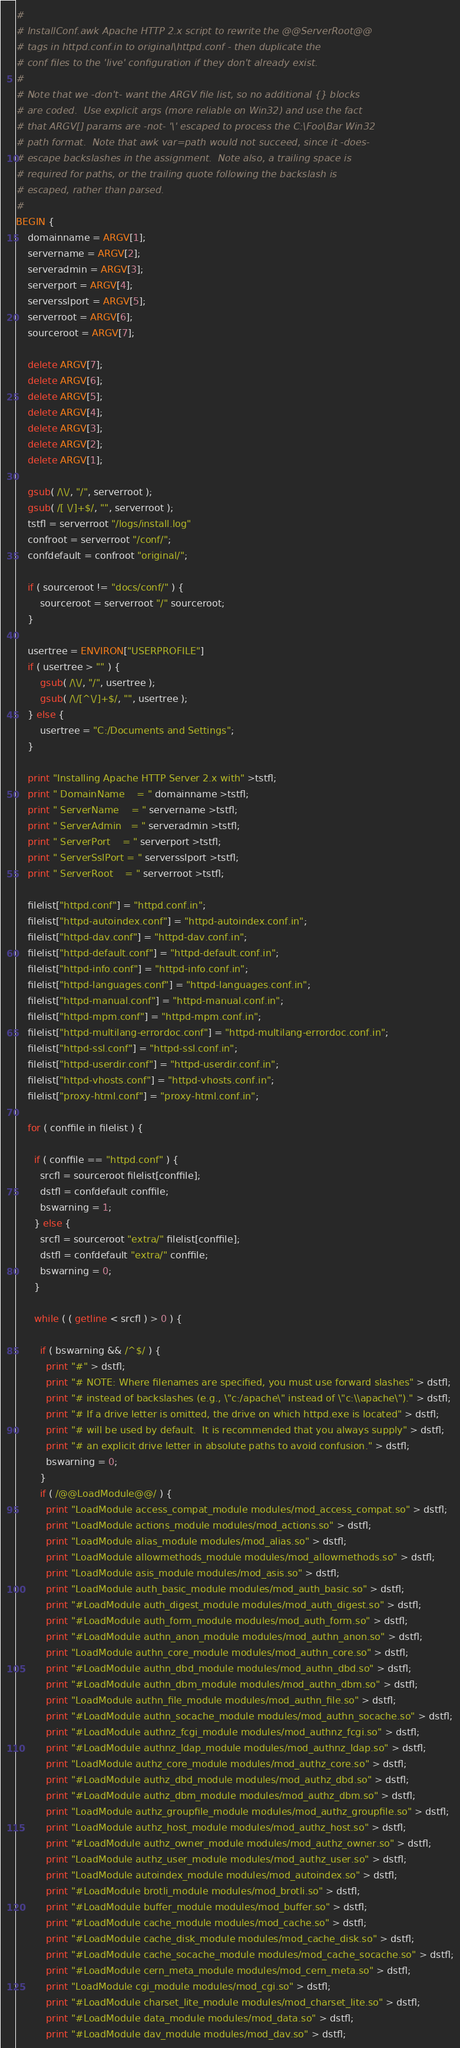<code> <loc_0><loc_0><loc_500><loc_500><_Awk_>#
# InstallConf.awk Apache HTTP 2.x script to rewrite the @@ServerRoot@@
# tags in httpd.conf.in to original\httpd.conf - then duplicate the
# conf files to the 'live' configuration if they don't already exist.
#
# Note that we -don't- want the ARGV file list, so no additional {} blocks
# are coded.  Use explicit args (more reliable on Win32) and use the fact
# that ARGV[] params are -not- '\' escaped to process the C:\Foo\Bar Win32
# path format.  Note that awk var=path would not succeed, since it -does-
# escape backslashes in the assignment.  Note also, a trailing space is
# required for paths, or the trailing quote following the backslash is
# escaped, rather than parsed.
#
BEGIN {
    domainname = ARGV[1];
    servername = ARGV[2];
    serveradmin = ARGV[3];
    serverport = ARGV[4];
    serversslport = ARGV[5];
    serverroot = ARGV[6];
    sourceroot = ARGV[7];

    delete ARGV[7];
    delete ARGV[6];
    delete ARGV[5];
    delete ARGV[4];
    delete ARGV[3];
    delete ARGV[2];
    delete ARGV[1];

    gsub( /\\/, "/", serverroot );
    gsub( /[ \/]+$/, "", serverroot );
    tstfl = serverroot "/logs/install.log"
    confroot = serverroot "/conf/";
    confdefault = confroot "original/";

    if ( sourceroot != "docs/conf/" ) {
        sourceroot = serverroot "/" sourceroot;
    }

    usertree = ENVIRON["USERPROFILE"]
    if ( usertree > "" ) {
        gsub( /\\/, "/", usertree );
        gsub( /\/[^\/]+$/, "", usertree );
    } else {
        usertree = "C:/Documents and Settings";
    }

    print "Installing Apache HTTP Server 2.x with" >tstfl;
    print " DomainName    = " domainname >tstfl;
    print " ServerName    = " servername >tstfl;
    print " ServerAdmin   = " serveradmin >tstfl;
    print " ServerPort    = " serverport >tstfl;
    print " ServerSslPort = " serversslport >tstfl;
    print " ServerRoot    = " serverroot >tstfl;

    filelist["httpd.conf"] = "httpd.conf.in";
    filelist["httpd-autoindex.conf"] = "httpd-autoindex.conf.in";
    filelist["httpd-dav.conf"] = "httpd-dav.conf.in";
    filelist["httpd-default.conf"] = "httpd-default.conf.in";
    filelist["httpd-info.conf"] = "httpd-info.conf.in";
    filelist["httpd-languages.conf"] = "httpd-languages.conf.in";
    filelist["httpd-manual.conf"] = "httpd-manual.conf.in";
    filelist["httpd-mpm.conf"] = "httpd-mpm.conf.in";
    filelist["httpd-multilang-errordoc.conf"] = "httpd-multilang-errordoc.conf.in";
    filelist["httpd-ssl.conf"] = "httpd-ssl.conf.in";
    filelist["httpd-userdir.conf"] = "httpd-userdir.conf.in";
    filelist["httpd-vhosts.conf"] = "httpd-vhosts.conf.in";
    filelist["proxy-html.conf"] = "proxy-html.conf.in";

    for ( conffile in filelist ) {

      if ( conffile == "httpd.conf" ) {
        srcfl = sourceroot filelist[conffile];
        dstfl = confdefault conffile;
        bswarning = 1;
      } else {
        srcfl = sourceroot "extra/" filelist[conffile];
        dstfl = confdefault "extra/" conffile;
        bswarning = 0;
      }

      while ( ( getline < srcfl ) > 0 ) {

        if ( bswarning && /^$/ ) {
          print "#" > dstfl;
          print "# NOTE: Where filenames are specified, you must use forward slashes" > dstfl;
          print "# instead of backslashes (e.g., \"c:/apache\" instead of \"c:\\apache\")." > dstfl;
          print "# If a drive letter is omitted, the drive on which httpd.exe is located" > dstfl;
          print "# will be used by default.  It is recommended that you always supply" > dstfl;
          print "# an explicit drive letter in absolute paths to avoid confusion." > dstfl;
          bswarning = 0;
        }
        if ( /@@LoadModule@@/ ) {
          print "LoadModule access_compat_module modules/mod_access_compat.so" > dstfl;
          print "LoadModule actions_module modules/mod_actions.so" > dstfl;
          print "LoadModule alias_module modules/mod_alias.so" > dstfl;
          print "LoadModule allowmethods_module modules/mod_allowmethods.so" > dstfl;
          print "LoadModule asis_module modules/mod_asis.so" > dstfl;
          print "LoadModule auth_basic_module modules/mod_auth_basic.so" > dstfl;
          print "#LoadModule auth_digest_module modules/mod_auth_digest.so" > dstfl;
          print "#LoadModule auth_form_module modules/mod_auth_form.so" > dstfl;
          print "#LoadModule authn_anon_module modules/mod_authn_anon.so" > dstfl;
          print "LoadModule authn_core_module modules/mod_authn_core.so" > dstfl;
          print "#LoadModule authn_dbd_module modules/mod_authn_dbd.so" > dstfl;
          print "#LoadModule authn_dbm_module modules/mod_authn_dbm.so" > dstfl;
          print "LoadModule authn_file_module modules/mod_authn_file.so" > dstfl;
          print "#LoadModule authn_socache_module modules/mod_authn_socache.so" > dstfl;
          print "#LoadModule authnz_fcgi_module modules/mod_authnz_fcgi.so" > dstfl;
          print "#LoadModule authnz_ldap_module modules/mod_authnz_ldap.so" > dstfl;
          print "LoadModule authz_core_module modules/mod_authz_core.so" > dstfl;
          print "#LoadModule authz_dbd_module modules/mod_authz_dbd.so" > dstfl;
          print "#LoadModule authz_dbm_module modules/mod_authz_dbm.so" > dstfl;
          print "LoadModule authz_groupfile_module modules/mod_authz_groupfile.so" > dstfl;
          print "LoadModule authz_host_module modules/mod_authz_host.so" > dstfl;
          print "#LoadModule authz_owner_module modules/mod_authz_owner.so" > dstfl;
          print "LoadModule authz_user_module modules/mod_authz_user.so" > dstfl;
          print "LoadModule autoindex_module modules/mod_autoindex.so" > dstfl;
          print "#LoadModule brotli_module modules/mod_brotli.so" > dstfl;
          print "#LoadModule buffer_module modules/mod_buffer.so" > dstfl;
          print "#LoadModule cache_module modules/mod_cache.so" > dstfl;
          print "#LoadModule cache_disk_module modules/mod_cache_disk.so" > dstfl;
          print "#LoadModule cache_socache_module modules/mod_cache_socache.so" > dstfl;
          print "#LoadModule cern_meta_module modules/mod_cern_meta.so" > dstfl;
          print "LoadModule cgi_module modules/mod_cgi.so" > dstfl;
          print "#LoadModule charset_lite_module modules/mod_charset_lite.so" > dstfl;
          print "#LoadModule data_module modules/mod_data.so" > dstfl;
          print "#LoadModule dav_module modules/mod_dav.so" > dstfl;</code> 